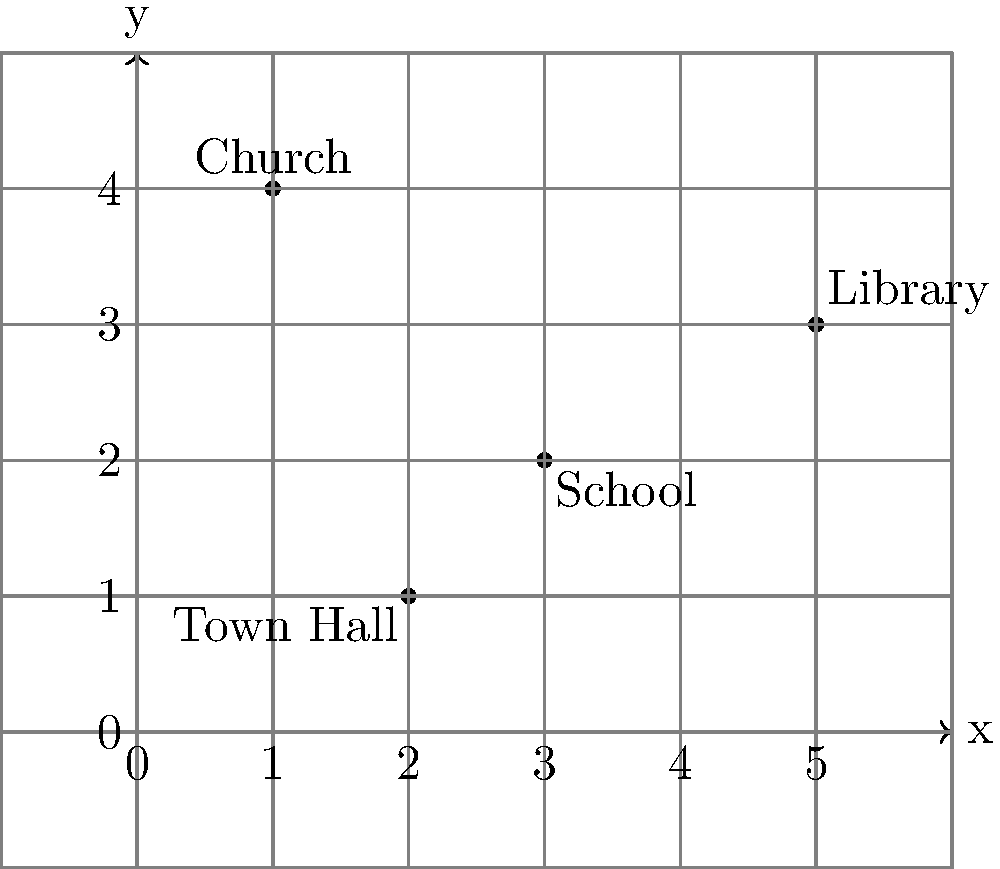In our small town, we have four important locations plotted on a coordinate grid: the Church, School, Library, and Town Hall. If we were to draw a rectangle using the Church and the Library as opposite corners, what would be the coordinates of the other two corners of this rectangle? To solve this problem, let's follow these steps:

1. Identify the coordinates of the Church and Library:
   Church: $(1,4)$
   Library: $(5,3)$

2. Recognize that these points form opposite corners of a rectangle.

3. To find the other two corners, we need to create points that share an x-coordinate with one point and a y-coordinate with the other:
   - One corner will have the x-coordinate of the Church and the y-coordinate of the Library
   - The other corner will have the x-coordinate of the Library and the y-coordinate of the Church

4. Calculate the coordinates:
   - Corner 1: $(1,3)$ (x from Church, y from Library)
   - Corner 2: $(5,4)$ (x from Library, y from Church)

5. Verify that these four points indeed form a rectangle by checking if opposite sides are parallel and equal in length.

Therefore, the other two corners of the rectangle are at $(1,3)$ and $(5,4)$.
Answer: $(1,3)$ and $(5,4)$ 